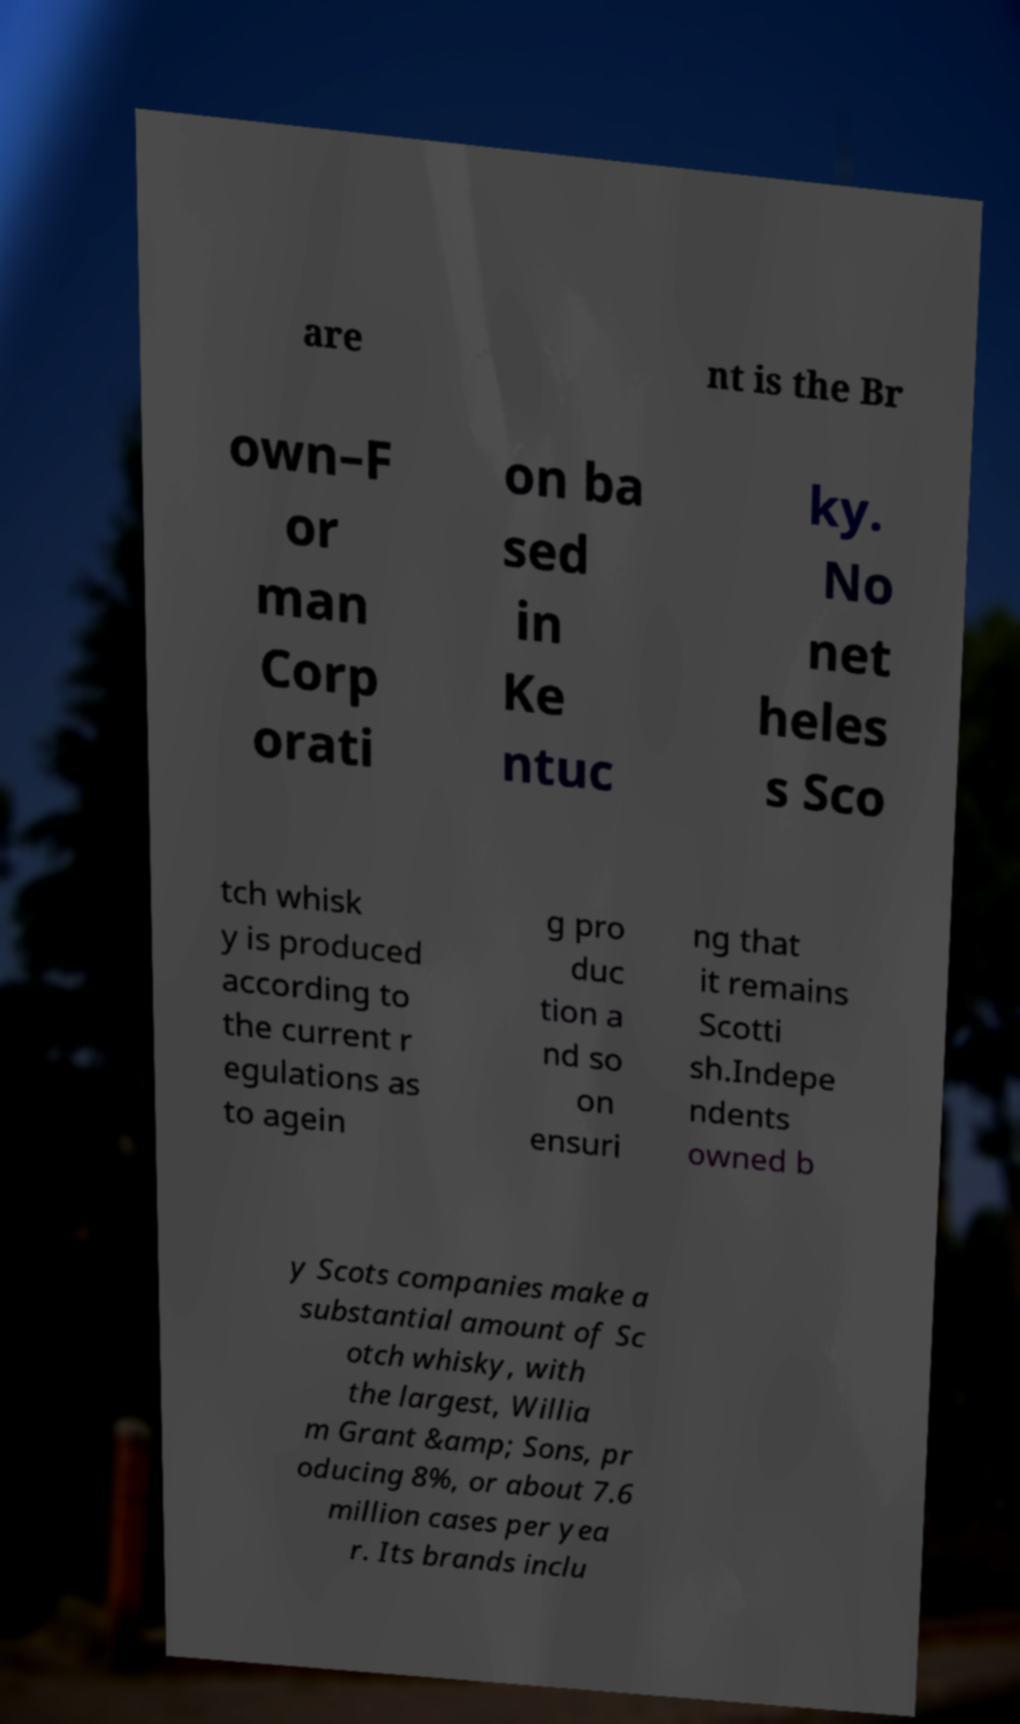For documentation purposes, I need the text within this image transcribed. Could you provide that? are nt is the Br own–F or man Corp orati on ba sed in Ke ntuc ky. No net heles s Sco tch whisk y is produced according to the current r egulations as to agein g pro duc tion a nd so on ensuri ng that it remains Scotti sh.Indepe ndents owned b y Scots companies make a substantial amount of Sc otch whisky, with the largest, Willia m Grant &amp; Sons, pr oducing 8%, or about 7.6 million cases per yea r. Its brands inclu 